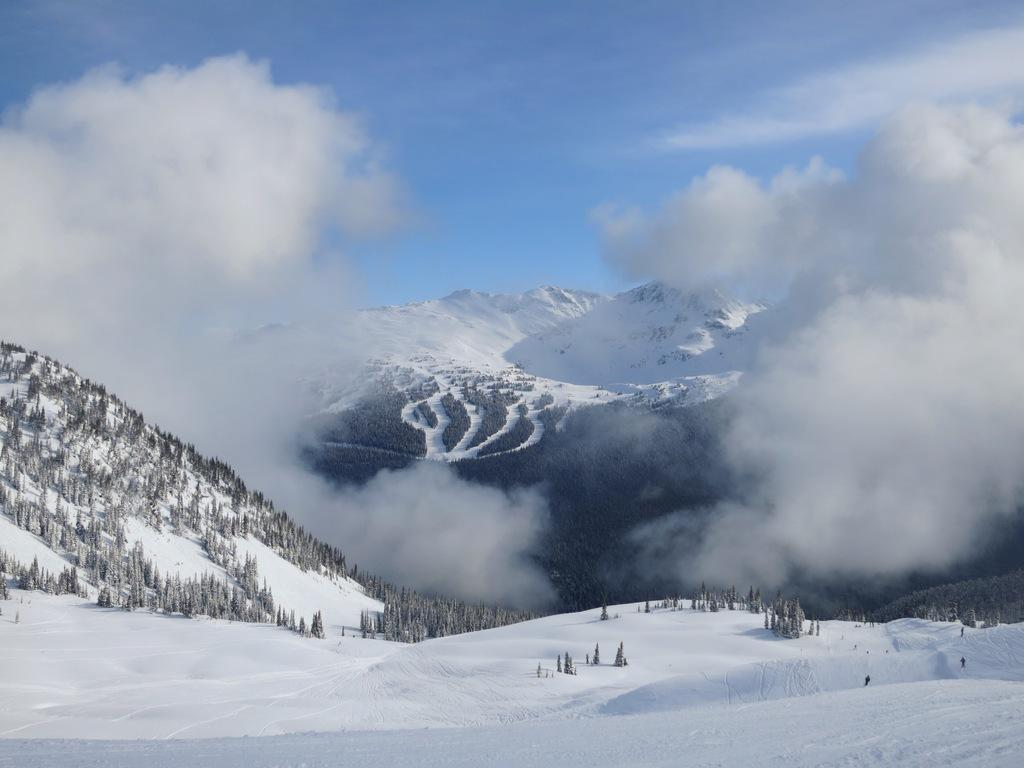What type of natural formation can be seen in the image? There are mountains in the image. What is the condition of the mountains in the image? The mountains are covered with snow. What type of vegetation is present in the image? There are trees in the image. What is the condition of the trees in the image? The trees are covered with snow. What can be seen in the background of the image? There are clouds in the background of the image. What type of finger can be seen holding a cart in the image? There is no finger or cart present in the image; it features mountains and trees covered in snow. 